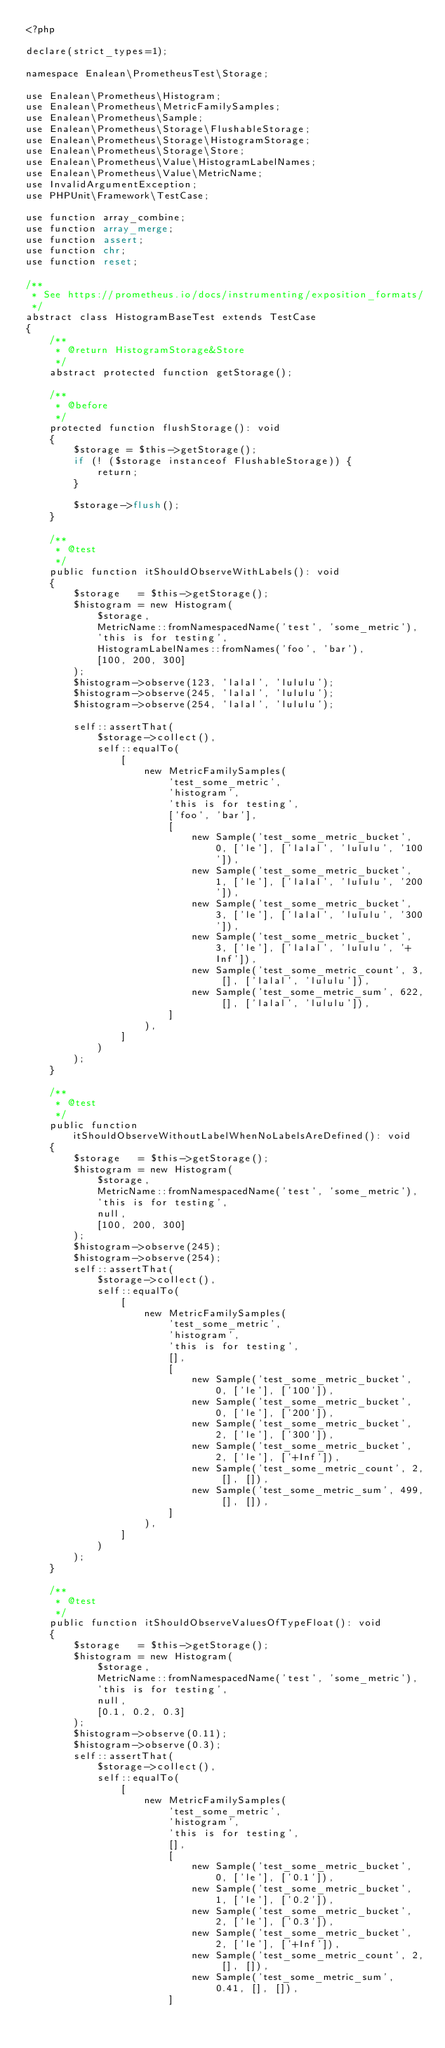Convert code to text. <code><loc_0><loc_0><loc_500><loc_500><_PHP_><?php

declare(strict_types=1);

namespace Enalean\PrometheusTest\Storage;

use Enalean\Prometheus\Histogram;
use Enalean\Prometheus\MetricFamilySamples;
use Enalean\Prometheus\Sample;
use Enalean\Prometheus\Storage\FlushableStorage;
use Enalean\Prometheus\Storage\HistogramStorage;
use Enalean\Prometheus\Storage\Store;
use Enalean\Prometheus\Value\HistogramLabelNames;
use Enalean\Prometheus\Value\MetricName;
use InvalidArgumentException;
use PHPUnit\Framework\TestCase;

use function array_combine;
use function array_merge;
use function assert;
use function chr;
use function reset;

/**
 * See https://prometheus.io/docs/instrumenting/exposition_formats/
 */
abstract class HistogramBaseTest extends TestCase
{
    /**
     * @return HistogramStorage&Store
     */
    abstract protected function getStorage();

    /**
     * @before
     */
    protected function flushStorage(): void
    {
        $storage = $this->getStorage();
        if (! ($storage instanceof FlushableStorage)) {
            return;
        }

        $storage->flush();
    }

    /**
     * @test
     */
    public function itShouldObserveWithLabels(): void
    {
        $storage   = $this->getStorage();
        $histogram = new Histogram(
            $storage,
            MetricName::fromNamespacedName('test', 'some_metric'),
            'this is for testing',
            HistogramLabelNames::fromNames('foo', 'bar'),
            [100, 200, 300]
        );
        $histogram->observe(123, 'lalal', 'lululu');
        $histogram->observe(245, 'lalal', 'lululu');
        $histogram->observe(254, 'lalal', 'lululu');

        self::assertThat(
            $storage->collect(),
            self::equalTo(
                [
                    new MetricFamilySamples(
                        'test_some_metric',
                        'histogram',
                        'this is for testing',
                        ['foo', 'bar'],
                        [
                            new Sample('test_some_metric_bucket', 0, ['le'], ['lalal', 'lululu', '100']),
                            new Sample('test_some_metric_bucket', 1, ['le'], ['lalal', 'lululu', '200']),
                            new Sample('test_some_metric_bucket', 3, ['le'], ['lalal', 'lululu', '300']),
                            new Sample('test_some_metric_bucket', 3, ['le'], ['lalal', 'lululu', '+Inf']),
                            new Sample('test_some_metric_count', 3, [], ['lalal', 'lululu']),
                            new Sample('test_some_metric_sum', 622, [], ['lalal', 'lululu']),
                        ]
                    ),
                ]
            )
        );
    }

    /**
     * @test
     */
    public function itShouldObserveWithoutLabelWhenNoLabelsAreDefined(): void
    {
        $storage   = $this->getStorage();
        $histogram = new Histogram(
            $storage,
            MetricName::fromNamespacedName('test', 'some_metric'),
            'this is for testing',
            null,
            [100, 200, 300]
        );
        $histogram->observe(245);
        $histogram->observe(254);
        self::assertThat(
            $storage->collect(),
            self::equalTo(
                [
                    new MetricFamilySamples(
                        'test_some_metric',
                        'histogram',
                        'this is for testing',
                        [],
                        [
                            new Sample('test_some_metric_bucket', 0, ['le'], ['100']),
                            new Sample('test_some_metric_bucket', 0, ['le'], ['200']),
                            new Sample('test_some_metric_bucket', 2, ['le'], ['300']),
                            new Sample('test_some_metric_bucket', 2, ['le'], ['+Inf']),
                            new Sample('test_some_metric_count', 2, [], []),
                            new Sample('test_some_metric_sum', 499, [], []),
                        ]
                    ),
                ]
            )
        );
    }

    /**
     * @test
     */
    public function itShouldObserveValuesOfTypeFloat(): void
    {
        $storage   = $this->getStorage();
        $histogram = new Histogram(
            $storage,
            MetricName::fromNamespacedName('test', 'some_metric'),
            'this is for testing',
            null,
            [0.1, 0.2, 0.3]
        );
        $histogram->observe(0.11);
        $histogram->observe(0.3);
        self::assertThat(
            $storage->collect(),
            self::equalTo(
                [
                    new MetricFamilySamples(
                        'test_some_metric',
                        'histogram',
                        'this is for testing',
                        [],
                        [
                            new Sample('test_some_metric_bucket', 0, ['le'], ['0.1']),
                            new Sample('test_some_metric_bucket', 1, ['le'], ['0.2']),
                            new Sample('test_some_metric_bucket', 2, ['le'], ['0.3']),
                            new Sample('test_some_metric_bucket', 2, ['le'], ['+Inf']),
                            new Sample('test_some_metric_count', 2, [], []),
                            new Sample('test_some_metric_sum', 0.41, [], []),
                        ]</code> 